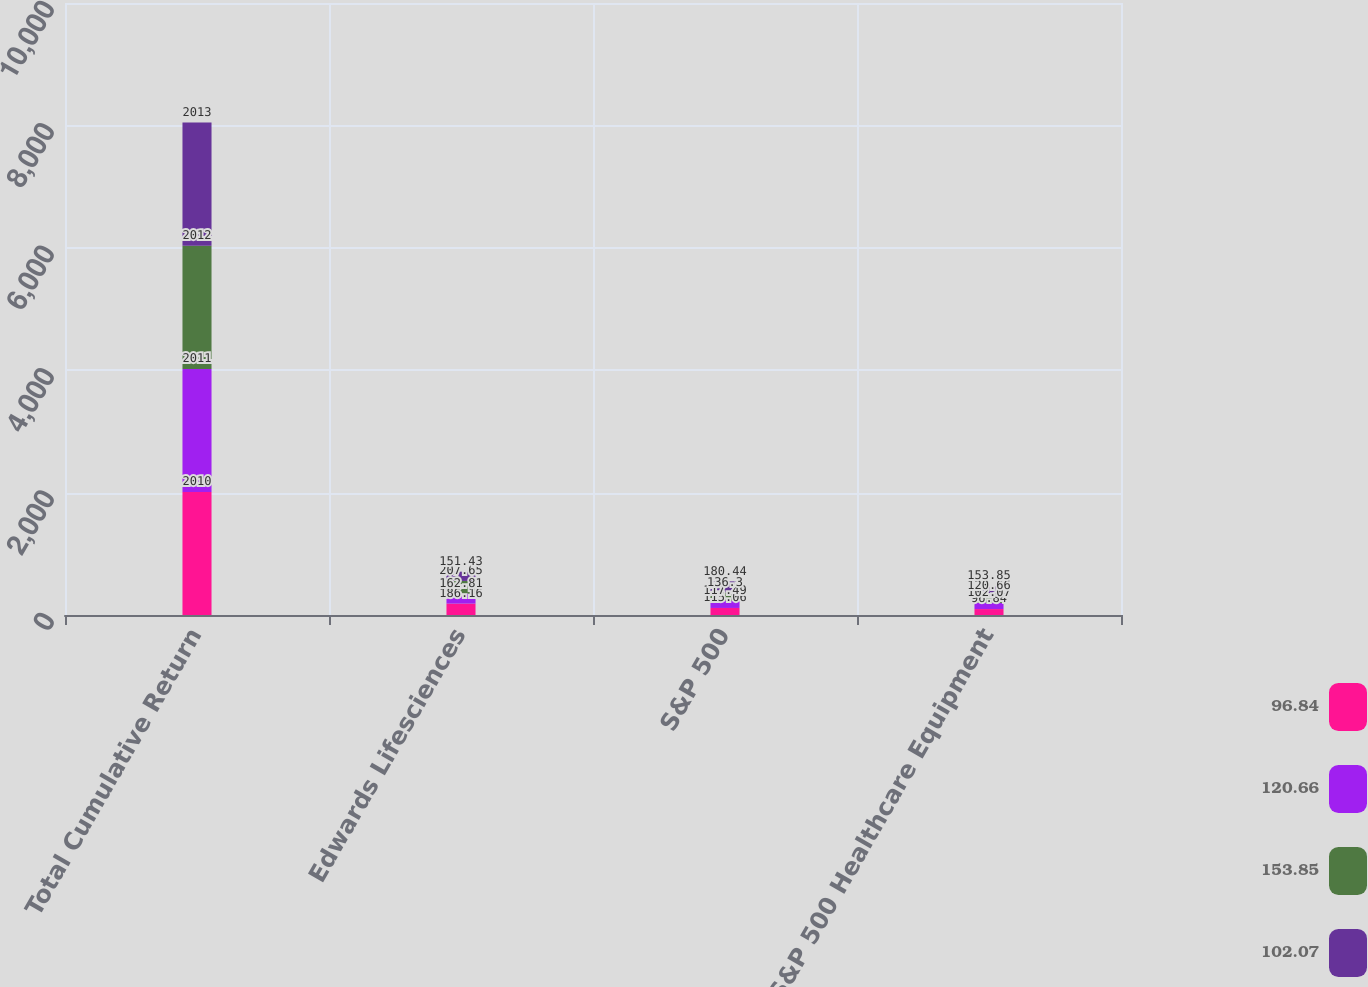Convert chart. <chart><loc_0><loc_0><loc_500><loc_500><stacked_bar_chart><ecel><fcel>Total Cumulative Return<fcel>Edwards Lifesciences<fcel>S&P 500<fcel>S&P 500 Healthcare Equipment<nl><fcel>96.84<fcel>2010<fcel>186.16<fcel>115.06<fcel>96.84<nl><fcel>120.66<fcel>2011<fcel>162.81<fcel>117.49<fcel>102.07<nl><fcel>153.85<fcel>2012<fcel>207.65<fcel>136.3<fcel>120.66<nl><fcel>102.07<fcel>2013<fcel>151.43<fcel>180.44<fcel>153.85<nl></chart> 